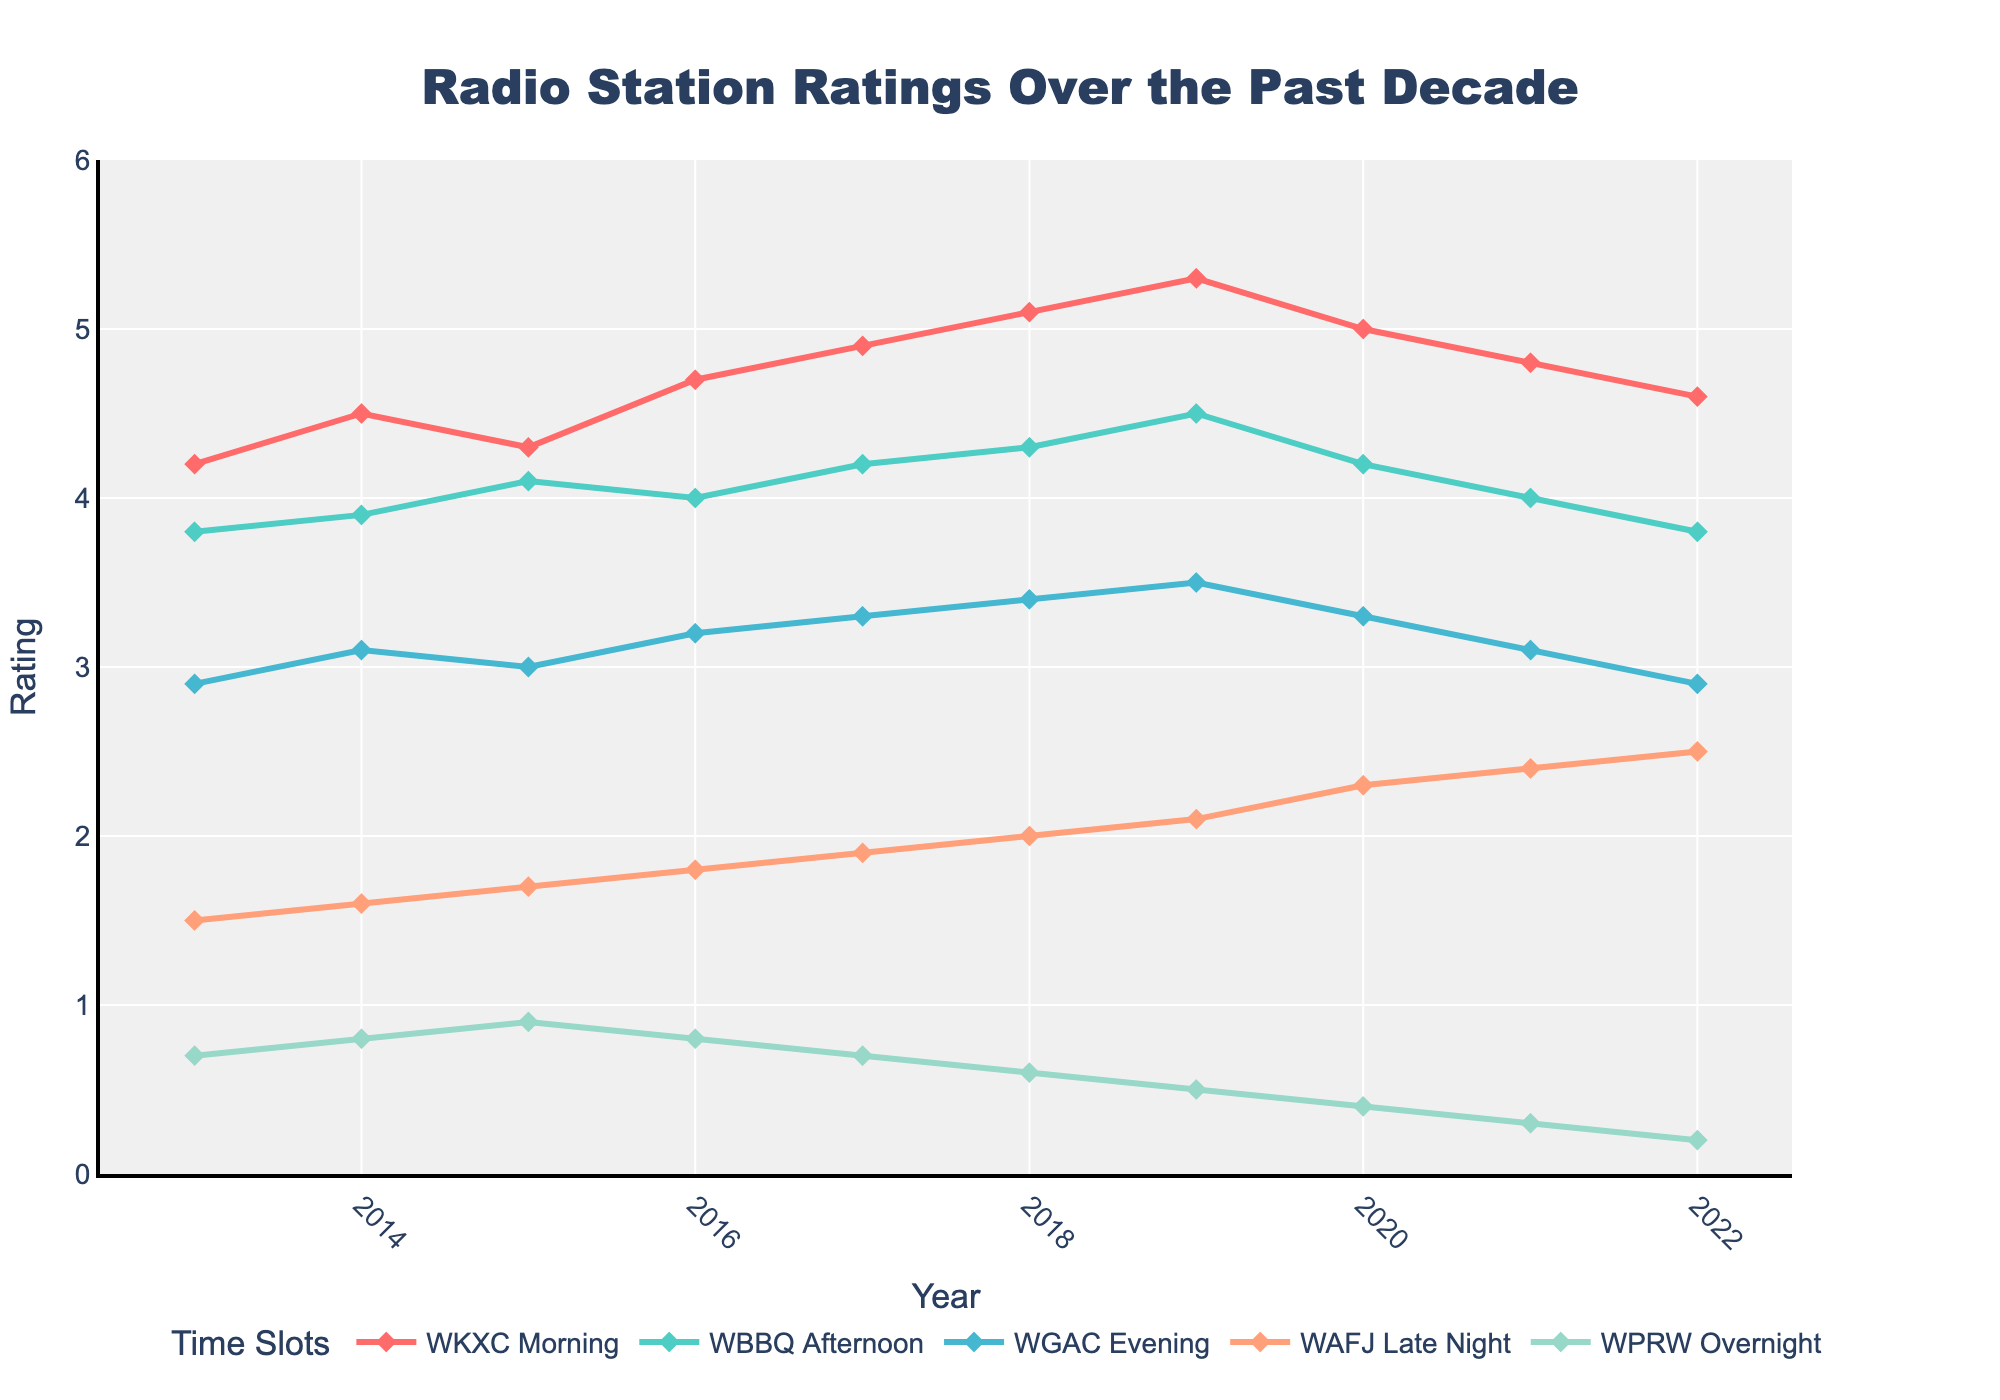What is the trend of WKXC Morning ratings over the past decade? Start by identifying the line that represents WKXC Morning. Notice that the ratings for WKXC Morning increase from 4.2 in 2013 to a peak of 5.3 in 2019, then slightly decrease to 4.6 in 2022.
Answer: Increasing until 2019, then decreasing Which station has the highest rating in 2022? Look at the ratings for all stations in 2022, and identify the one with the highest value. WKXC Morning has a rating of 4.6, which is higher than others.
Answer: WKXC Morning Which station has shown the most consistent ratings over the decade? Compare the overall fluctuation in ratings for each station. WGAC Evening has the smallest range of values (2.9 to 3.5), indicating the most consistent ratings.
Answer: WGAC Evening Comparing WBBQ Afternoon and WGAC Evening, which station's ratings have increased more from 2013 to 2022? Calculate the increase for both stations: WBBQ Afternoon (3.8 to 3.8, with no change) and WGAC Evening (2.9 to 2.9, with no change).
Answer: Both have no change What is the average rating for WAFJ Late Night over the past decade? Sum the ratings for WAFJ Late Night from 2013 to 2022 and divide by the number of years. (1.5 + 1.6 + 1.7 + 1.8 + 1.9 + 2.0 + 2.1 + 2.3 + 2.4 + 2.5) / 10 = 1.88
Answer: 1.88 In what year did WKXC Morning achieve its highest rating? Inspect the WKXC Morning line and identify its highest point, which occurs in 2019.
Answer: 2019 What is the difference between the highest and lowest ratings for WPRW Overnight over the decade? Calculate the difference between the highest (0.9 in 2015) and lowest (0.2 in 2022) ratings for WPRW Overnight. 0.9 - 0.2 = 0.7
Answer: 0.7 Which time slot rating has declined the most from 2019 to 2020? Compare the ratings from 2019 to 2020 for all time slots and find the one with the largest decrease. WKXC Morning decreased from 5.3 to 5.0, a decrease of 0.3, which is the largest.
Answer: WKXC Morning Which time slot showed the most improvement from 2021 to 2022? Observe the ratings from 2021 to 2022 for all time slots and identify the one with the largest increase. WAFJ Late Night increased from 2.4 to 2.5, an increase of 0.1.
Answer: WAFJ Late Night What are the ratings for WGAC Evening in 2016 and 2019, and what is their average? Look at the ratings for WGAC Evening in 2016 and 2019: 3.2 (2016) and 3.5 (2019). The average is (3.2 + 3.5) / 2 = 3.35
Answer: 3.35 